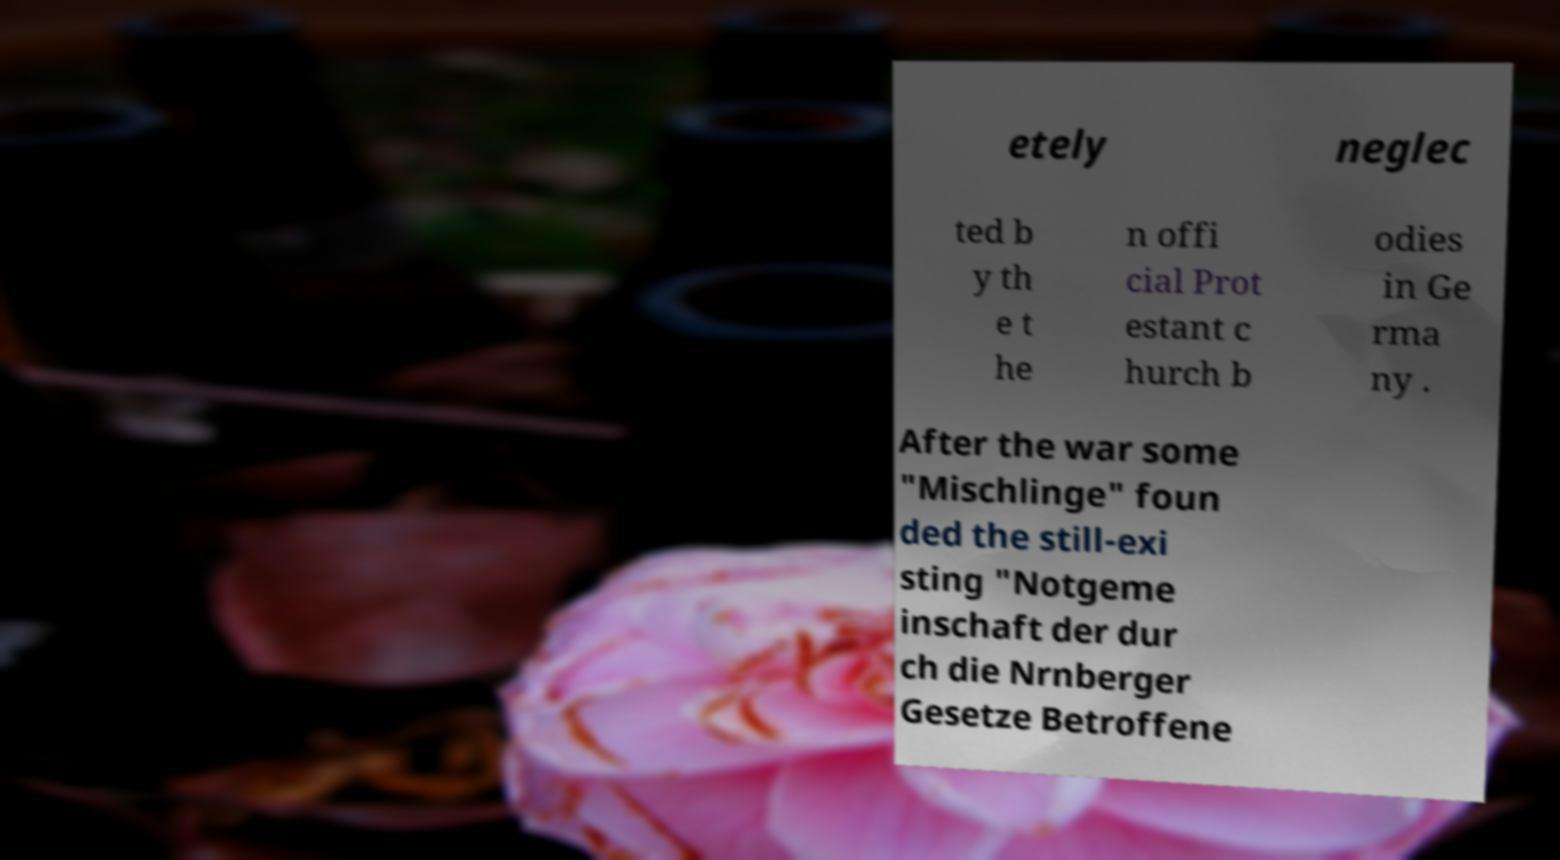Please read and relay the text visible in this image. What does it say? etely neglec ted b y th e t he n offi cial Prot estant c hurch b odies in Ge rma ny . After the war some "Mischlinge" foun ded the still-exi sting "Notgeme inschaft der dur ch die Nrnberger Gesetze Betroffene 